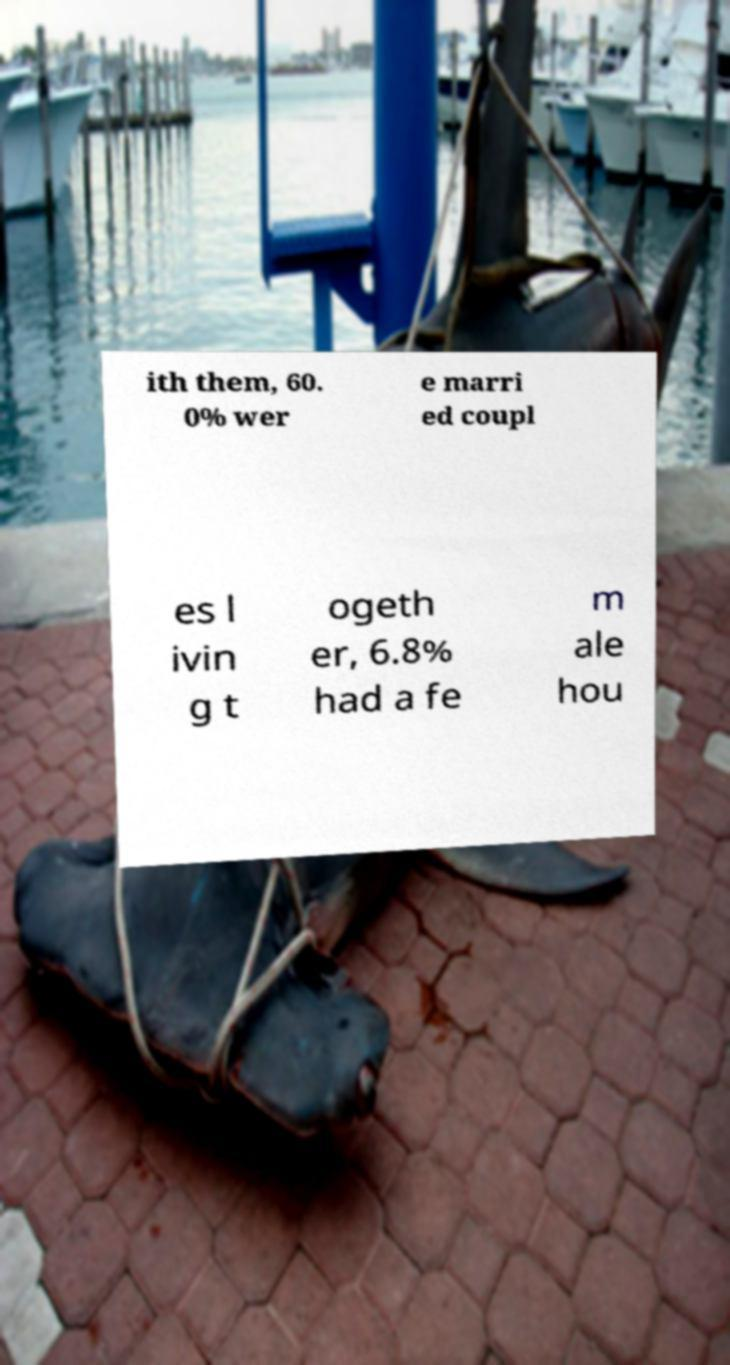Could you assist in decoding the text presented in this image and type it out clearly? ith them, 60. 0% wer e marri ed coupl es l ivin g t ogeth er, 6.8% had a fe m ale hou 